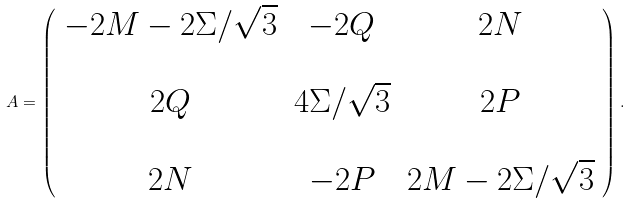<formula> <loc_0><loc_0><loc_500><loc_500>A = \left ( \begin{array} { c c c } - 2 M - 2 \Sigma / \sqrt { 3 } & - 2 Q & 2 N \\ & & \\ 2 Q & 4 \Sigma / \sqrt { 3 } & 2 P \\ & & \\ 2 N & - 2 P & 2 M - 2 \Sigma / \sqrt { 3 } \end{array} \right ) .</formula> 